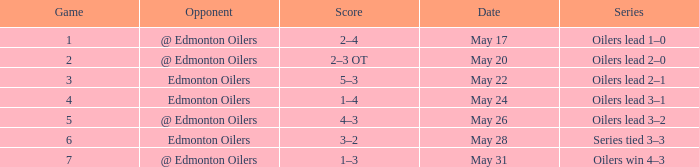Opponent of @ edmonton oilers, and a Game larger than 1, and a Series of oilers lead 3–2 had what score? 4–3. 